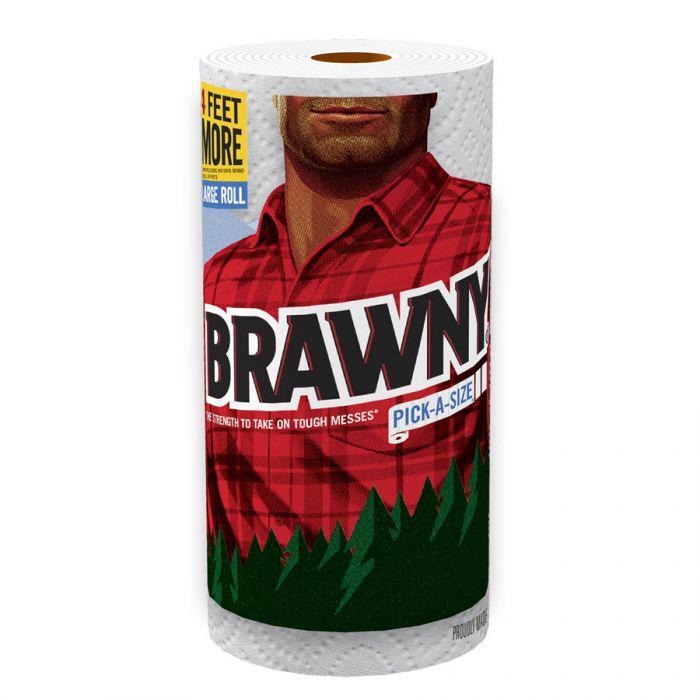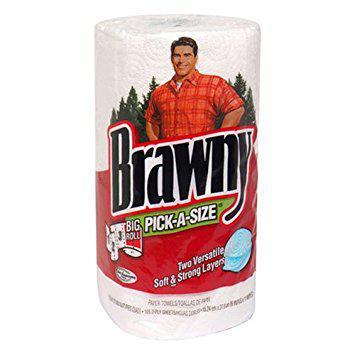The first image is the image on the left, the second image is the image on the right. Analyze the images presented: Is the assertion "There are at least six rolls of paper towels in the package on the left." valid? Answer yes or no. No. The first image is the image on the left, the second image is the image on the right. Analyze the images presented: Is the assertion "At least one image contains a single upright paper towel roll in a wrapper that features a red plaid shirt." valid? Answer yes or no. Yes. 